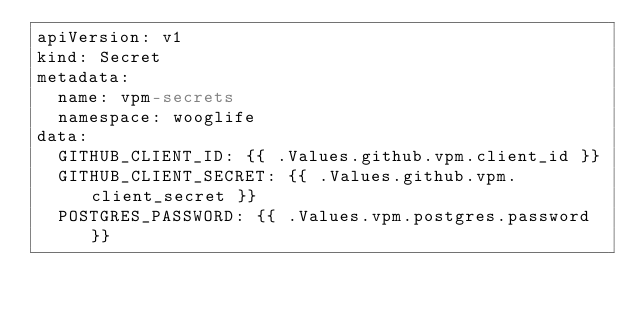<code> <loc_0><loc_0><loc_500><loc_500><_YAML_>apiVersion: v1
kind: Secret
metadata:
  name: vpm-secrets
  namespace: wooglife
data:
  GITHUB_CLIENT_ID: {{ .Values.github.vpm.client_id }}
  GITHUB_CLIENT_SECRET: {{ .Values.github.vpm.client_secret }}
  POSTGRES_PASSWORD: {{ .Values.vpm.postgres.password }}
</code> 